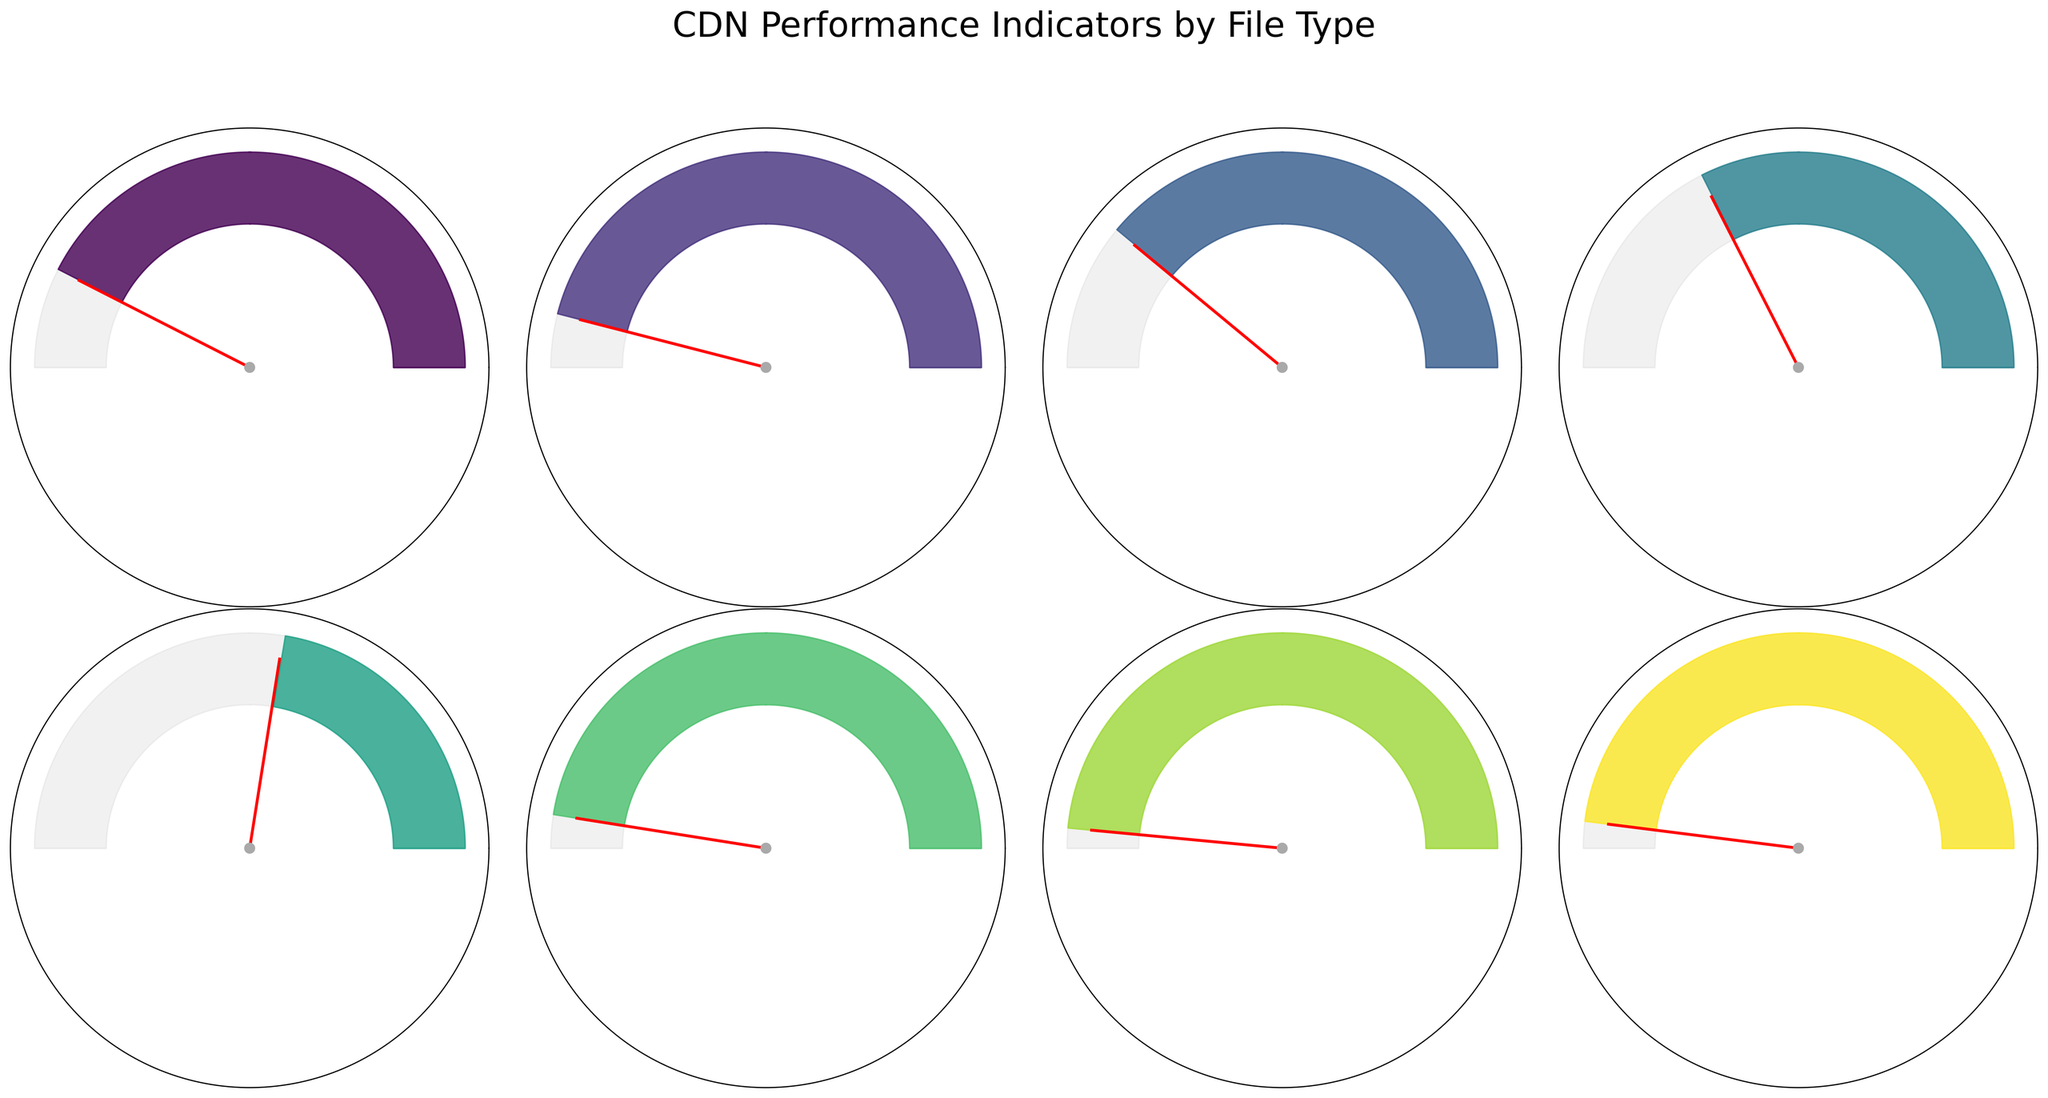Which file type has the highest performance score? Look at the performance score at the bottom of each gauge chart. Compare all scores, the highest one is 0.97 for the JSON file type.
Answer: JSON What is the average load time for images and videos combined? Add the average load times of images and videos and divide by the number of file types (2). The math: (450 ms + 750 ms) / 2 = 600 ms.
Answer: 600 ms Which file type has the lowest performance score, and what is its average load time? Identify the gauge chart with the lowest performance score of 0.45, which is for the video file type. The corresponding average load time is displayed as 750 ms.
Answer: Videos, 750 ms How many file types have a performance score greater than 0.9? Count the file types where the performance score is listed above 0.9. These are CSS (0.92), Fonts (0.95), JSON (0.97), and XML (0.96), totaling 4 file types.
Answer: 4 If you aim to reduce the loading time of the file type with the longest load time to match that of the next highest, how much time should be reduced? Videos have the longest load time of 750 ms. The next highest is images with 450 ms. Calculate the difference: 750 ms - 450 ms = 300 ms.
Answer: 300 ms Which two file types have the closest performance scores? Compare each performance score to find the smallest difference. JSON (0.97) and XML (0.96) have the closest scores with a difference of 0.01.
Answer: JSON and XML What is the total average load time for all file types combined? Sum the average load times for all file types and divide by the number of file types (8). Calculation: (250 + 180 + 320 + 450 + 750 + 150 + 120 + 140) / 8 = 295 ms.
Answer: 295 ms What file type shows the quickest average load time? Identify the smallest value in the average load time, which for JSON is 120 ms.
Answer: JSON Which file type has a performance score closest to 0.8? Identify the performance score closest to 0.8. JavaScript has a score of 0.78, which is the closest.
Answer: JavaScript Which file type has both a low load time and a high performance score? Look for a combination of low average load time (below 200 ms) and high performance score (above 0.9). JSON fits this with 120 ms load time and a score of 0.97.
Answer: JSON 